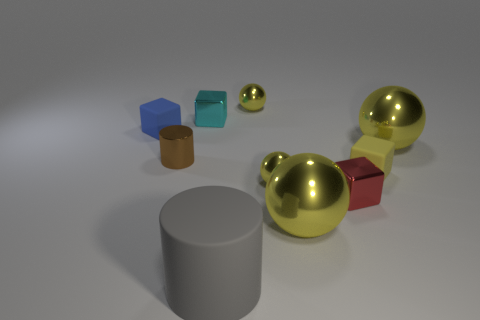How many things are either brown objects or matte objects?
Give a very brief answer. 4. What is the color of the cylinder that is the same material as the tiny yellow block?
Keep it short and to the point. Gray. There is a small yellow metallic object in front of the tiny blue cube; does it have the same shape as the yellow rubber object?
Make the answer very short. No. How many objects are either tiny yellow spheres that are behind the small brown thing or things that are on the right side of the blue matte thing?
Offer a terse response. 9. What color is the other object that is the same shape as the tiny brown shiny object?
Provide a short and direct response. Gray. Is there anything else that is the same shape as the small brown object?
Provide a succinct answer. Yes. There is a cyan metallic thing; is its shape the same as the large matte thing that is in front of the red shiny block?
Give a very brief answer. No. What is the material of the tiny brown cylinder?
Your answer should be compact. Metal. What is the size of the other metallic object that is the same shape as the gray thing?
Make the answer very short. Small. How many other objects are there of the same material as the small red cube?
Keep it short and to the point. 6. 